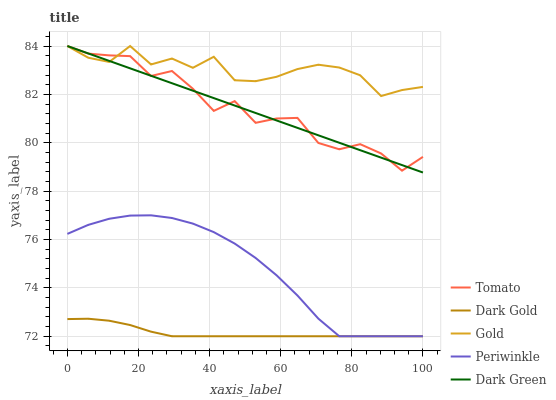Does Dark Green have the minimum area under the curve?
Answer yes or no. No. Does Dark Green have the maximum area under the curve?
Answer yes or no. No. Is Periwinkle the smoothest?
Answer yes or no. No. Is Periwinkle the roughest?
Answer yes or no. No. Does Dark Green have the lowest value?
Answer yes or no. No. Does Periwinkle have the highest value?
Answer yes or no. No. Is Periwinkle less than Dark Green?
Answer yes or no. Yes. Is Tomato greater than Dark Gold?
Answer yes or no. Yes. Does Periwinkle intersect Dark Green?
Answer yes or no. No. 